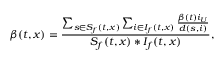<formula> <loc_0><loc_0><loc_500><loc_500>\beta ( t , x ) = \frac { \sum _ { s \in S _ { f } ( t , x ) } \sum _ { i \in I _ { f } ( t , x ) } \frac { \beta ( t ) i _ { U } } { d ( s , i ) } } { S _ { f } ( t , x ) * I _ { f } ( t , x ) } ,</formula> 